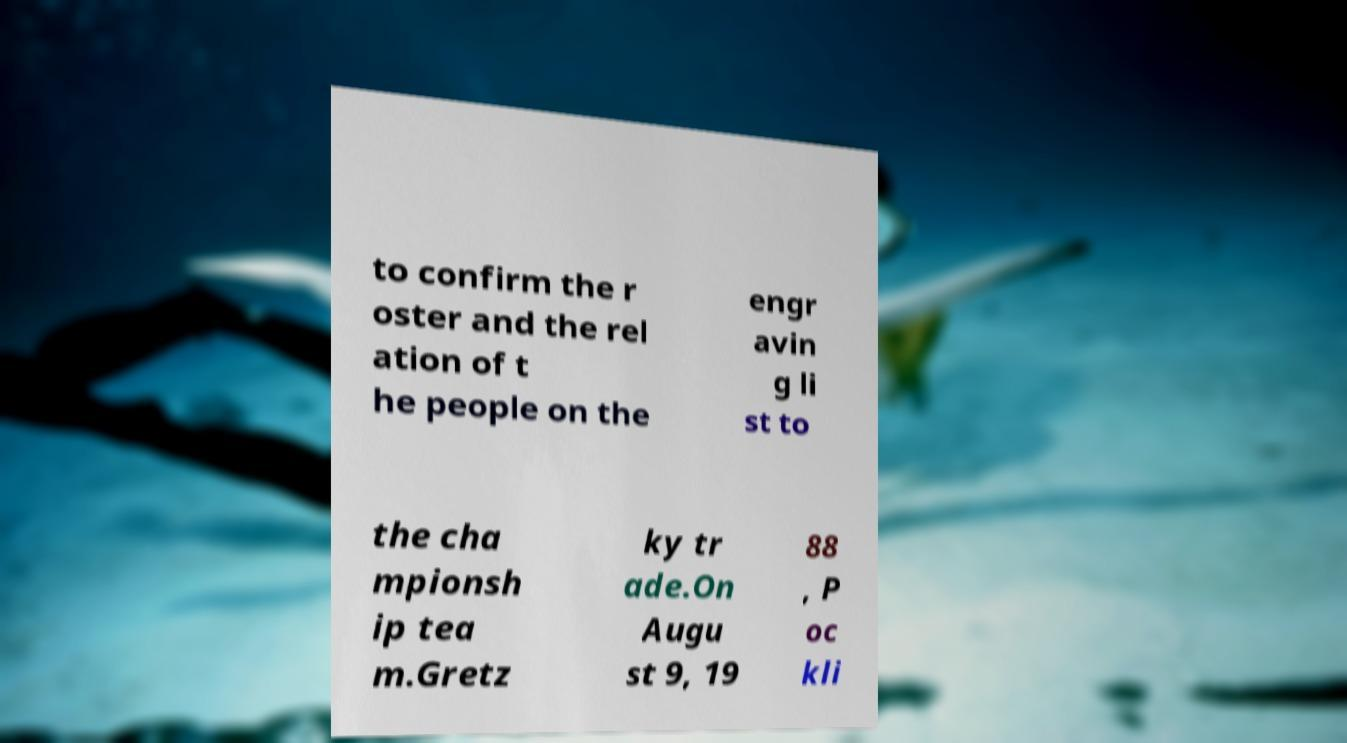For documentation purposes, I need the text within this image transcribed. Could you provide that? to confirm the r oster and the rel ation of t he people on the engr avin g li st to the cha mpionsh ip tea m.Gretz ky tr ade.On Augu st 9, 19 88 , P oc kli 